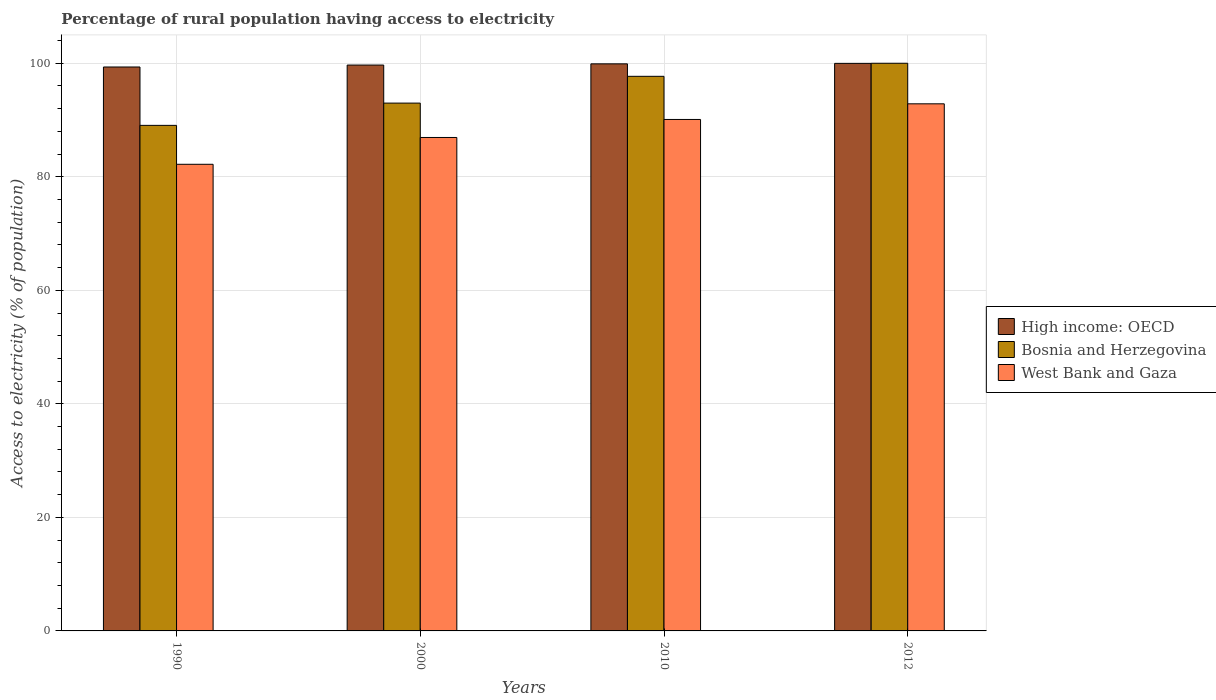Are the number of bars per tick equal to the number of legend labels?
Keep it short and to the point. Yes. Are the number of bars on each tick of the X-axis equal?
Make the answer very short. Yes. How many bars are there on the 3rd tick from the left?
Offer a terse response. 3. What is the percentage of rural population having access to electricity in West Bank and Gaza in 2010?
Your answer should be very brief. 90.1. Across all years, what is the maximum percentage of rural population having access to electricity in High income: OECD?
Your answer should be very brief. 99.98. Across all years, what is the minimum percentage of rural population having access to electricity in Bosnia and Herzegovina?
Provide a succinct answer. 89.06. In which year was the percentage of rural population having access to electricity in High income: OECD maximum?
Make the answer very short. 2012. In which year was the percentage of rural population having access to electricity in West Bank and Gaza minimum?
Your answer should be compact. 1990. What is the total percentage of rural population having access to electricity in Bosnia and Herzegovina in the graph?
Your response must be concise. 379.74. What is the difference between the percentage of rural population having access to electricity in Bosnia and Herzegovina in 1990 and that in 2000?
Provide a succinct answer. -3.92. What is the difference between the percentage of rural population having access to electricity in High income: OECD in 2000 and the percentage of rural population having access to electricity in Bosnia and Herzegovina in 2012?
Provide a succinct answer. -0.32. What is the average percentage of rural population having access to electricity in Bosnia and Herzegovina per year?
Your answer should be very brief. 94.94. In the year 2012, what is the difference between the percentage of rural population having access to electricity in West Bank and Gaza and percentage of rural population having access to electricity in High income: OECD?
Offer a very short reply. -7.13. What is the ratio of the percentage of rural population having access to electricity in Bosnia and Herzegovina in 2000 to that in 2012?
Provide a short and direct response. 0.93. Is the percentage of rural population having access to electricity in High income: OECD in 1990 less than that in 2012?
Offer a terse response. Yes. Is the difference between the percentage of rural population having access to electricity in West Bank and Gaza in 2010 and 2012 greater than the difference between the percentage of rural population having access to electricity in High income: OECD in 2010 and 2012?
Your answer should be very brief. No. What is the difference between the highest and the second highest percentage of rural population having access to electricity in High income: OECD?
Your answer should be very brief. 0.08. What is the difference between the highest and the lowest percentage of rural population having access to electricity in West Bank and Gaza?
Give a very brief answer. 10.65. What does the 1st bar from the left in 2010 represents?
Ensure brevity in your answer.  High income: OECD. What does the 2nd bar from the right in 1990 represents?
Your answer should be compact. Bosnia and Herzegovina. How many bars are there?
Offer a very short reply. 12. Are all the bars in the graph horizontal?
Keep it short and to the point. No. Does the graph contain grids?
Provide a short and direct response. Yes. Where does the legend appear in the graph?
Your answer should be very brief. Center right. How many legend labels are there?
Keep it short and to the point. 3. How are the legend labels stacked?
Give a very brief answer. Vertical. What is the title of the graph?
Your response must be concise. Percentage of rural population having access to electricity. Does "St. Kitts and Nevis" appear as one of the legend labels in the graph?
Give a very brief answer. No. What is the label or title of the Y-axis?
Provide a succinct answer. Access to electricity (% of population). What is the Access to electricity (% of population) in High income: OECD in 1990?
Your answer should be compact. 99.34. What is the Access to electricity (% of population) of Bosnia and Herzegovina in 1990?
Ensure brevity in your answer.  89.06. What is the Access to electricity (% of population) of West Bank and Gaza in 1990?
Provide a short and direct response. 82.2. What is the Access to electricity (% of population) in High income: OECD in 2000?
Your response must be concise. 99.68. What is the Access to electricity (% of population) in Bosnia and Herzegovina in 2000?
Make the answer very short. 92.98. What is the Access to electricity (% of population) of West Bank and Gaza in 2000?
Keep it short and to the point. 86.93. What is the Access to electricity (% of population) of High income: OECD in 2010?
Keep it short and to the point. 99.9. What is the Access to electricity (% of population) of Bosnia and Herzegovina in 2010?
Ensure brevity in your answer.  97.7. What is the Access to electricity (% of population) in West Bank and Gaza in 2010?
Provide a succinct answer. 90.1. What is the Access to electricity (% of population) of High income: OECD in 2012?
Your answer should be very brief. 99.98. What is the Access to electricity (% of population) of Bosnia and Herzegovina in 2012?
Make the answer very short. 100. What is the Access to electricity (% of population) in West Bank and Gaza in 2012?
Give a very brief answer. 92.85. Across all years, what is the maximum Access to electricity (% of population) of High income: OECD?
Make the answer very short. 99.98. Across all years, what is the maximum Access to electricity (% of population) in Bosnia and Herzegovina?
Offer a terse response. 100. Across all years, what is the maximum Access to electricity (% of population) of West Bank and Gaza?
Ensure brevity in your answer.  92.85. Across all years, what is the minimum Access to electricity (% of population) of High income: OECD?
Offer a terse response. 99.34. Across all years, what is the minimum Access to electricity (% of population) of Bosnia and Herzegovina?
Keep it short and to the point. 89.06. Across all years, what is the minimum Access to electricity (% of population) of West Bank and Gaza?
Your answer should be very brief. 82.2. What is the total Access to electricity (% of population) in High income: OECD in the graph?
Your answer should be compact. 398.9. What is the total Access to electricity (% of population) of Bosnia and Herzegovina in the graph?
Keep it short and to the point. 379.74. What is the total Access to electricity (% of population) in West Bank and Gaza in the graph?
Provide a short and direct response. 352.08. What is the difference between the Access to electricity (% of population) of High income: OECD in 1990 and that in 2000?
Your answer should be compact. -0.34. What is the difference between the Access to electricity (% of population) in Bosnia and Herzegovina in 1990 and that in 2000?
Provide a short and direct response. -3.92. What is the difference between the Access to electricity (% of population) in West Bank and Gaza in 1990 and that in 2000?
Keep it short and to the point. -4.72. What is the difference between the Access to electricity (% of population) of High income: OECD in 1990 and that in 2010?
Offer a very short reply. -0.55. What is the difference between the Access to electricity (% of population) of Bosnia and Herzegovina in 1990 and that in 2010?
Ensure brevity in your answer.  -8.64. What is the difference between the Access to electricity (% of population) in West Bank and Gaza in 1990 and that in 2010?
Offer a terse response. -7.9. What is the difference between the Access to electricity (% of population) in High income: OECD in 1990 and that in 2012?
Provide a succinct answer. -0.64. What is the difference between the Access to electricity (% of population) in Bosnia and Herzegovina in 1990 and that in 2012?
Offer a terse response. -10.94. What is the difference between the Access to electricity (% of population) of West Bank and Gaza in 1990 and that in 2012?
Ensure brevity in your answer.  -10.65. What is the difference between the Access to electricity (% of population) of High income: OECD in 2000 and that in 2010?
Ensure brevity in your answer.  -0.21. What is the difference between the Access to electricity (% of population) in Bosnia and Herzegovina in 2000 and that in 2010?
Your answer should be very brief. -4.72. What is the difference between the Access to electricity (% of population) in West Bank and Gaza in 2000 and that in 2010?
Provide a short and direct response. -3.17. What is the difference between the Access to electricity (% of population) in High income: OECD in 2000 and that in 2012?
Ensure brevity in your answer.  -0.3. What is the difference between the Access to electricity (% of population) of Bosnia and Herzegovina in 2000 and that in 2012?
Provide a succinct answer. -7.02. What is the difference between the Access to electricity (% of population) of West Bank and Gaza in 2000 and that in 2012?
Offer a very short reply. -5.93. What is the difference between the Access to electricity (% of population) of High income: OECD in 2010 and that in 2012?
Offer a terse response. -0.08. What is the difference between the Access to electricity (% of population) in West Bank and Gaza in 2010 and that in 2012?
Your answer should be compact. -2.75. What is the difference between the Access to electricity (% of population) of High income: OECD in 1990 and the Access to electricity (% of population) of Bosnia and Herzegovina in 2000?
Offer a very short reply. 6.36. What is the difference between the Access to electricity (% of population) in High income: OECD in 1990 and the Access to electricity (% of population) in West Bank and Gaza in 2000?
Give a very brief answer. 12.42. What is the difference between the Access to electricity (% of population) of Bosnia and Herzegovina in 1990 and the Access to electricity (% of population) of West Bank and Gaza in 2000?
Your answer should be compact. 2.13. What is the difference between the Access to electricity (% of population) of High income: OECD in 1990 and the Access to electricity (% of population) of Bosnia and Herzegovina in 2010?
Your answer should be very brief. 1.64. What is the difference between the Access to electricity (% of population) in High income: OECD in 1990 and the Access to electricity (% of population) in West Bank and Gaza in 2010?
Your answer should be compact. 9.24. What is the difference between the Access to electricity (% of population) of Bosnia and Herzegovina in 1990 and the Access to electricity (% of population) of West Bank and Gaza in 2010?
Your answer should be compact. -1.04. What is the difference between the Access to electricity (% of population) of High income: OECD in 1990 and the Access to electricity (% of population) of Bosnia and Herzegovina in 2012?
Make the answer very short. -0.66. What is the difference between the Access to electricity (% of population) of High income: OECD in 1990 and the Access to electricity (% of population) of West Bank and Gaza in 2012?
Your response must be concise. 6.49. What is the difference between the Access to electricity (% of population) of Bosnia and Herzegovina in 1990 and the Access to electricity (% of population) of West Bank and Gaza in 2012?
Your response must be concise. -3.79. What is the difference between the Access to electricity (% of population) in High income: OECD in 2000 and the Access to electricity (% of population) in Bosnia and Herzegovina in 2010?
Give a very brief answer. 1.98. What is the difference between the Access to electricity (% of population) of High income: OECD in 2000 and the Access to electricity (% of population) of West Bank and Gaza in 2010?
Offer a terse response. 9.58. What is the difference between the Access to electricity (% of population) of Bosnia and Herzegovina in 2000 and the Access to electricity (% of population) of West Bank and Gaza in 2010?
Your answer should be very brief. 2.88. What is the difference between the Access to electricity (% of population) of High income: OECD in 2000 and the Access to electricity (% of population) of Bosnia and Herzegovina in 2012?
Your answer should be compact. -0.32. What is the difference between the Access to electricity (% of population) in High income: OECD in 2000 and the Access to electricity (% of population) in West Bank and Gaza in 2012?
Offer a very short reply. 6.83. What is the difference between the Access to electricity (% of population) of Bosnia and Herzegovina in 2000 and the Access to electricity (% of population) of West Bank and Gaza in 2012?
Your answer should be very brief. 0.13. What is the difference between the Access to electricity (% of population) of High income: OECD in 2010 and the Access to electricity (% of population) of Bosnia and Herzegovina in 2012?
Ensure brevity in your answer.  -0.1. What is the difference between the Access to electricity (% of population) in High income: OECD in 2010 and the Access to electricity (% of population) in West Bank and Gaza in 2012?
Your response must be concise. 7.04. What is the difference between the Access to electricity (% of population) in Bosnia and Herzegovina in 2010 and the Access to electricity (% of population) in West Bank and Gaza in 2012?
Your answer should be compact. 4.85. What is the average Access to electricity (% of population) in High income: OECD per year?
Give a very brief answer. 99.73. What is the average Access to electricity (% of population) of Bosnia and Herzegovina per year?
Keep it short and to the point. 94.94. What is the average Access to electricity (% of population) of West Bank and Gaza per year?
Provide a succinct answer. 88.02. In the year 1990, what is the difference between the Access to electricity (% of population) of High income: OECD and Access to electricity (% of population) of Bosnia and Herzegovina?
Offer a terse response. 10.28. In the year 1990, what is the difference between the Access to electricity (% of population) in High income: OECD and Access to electricity (% of population) in West Bank and Gaza?
Your response must be concise. 17.14. In the year 1990, what is the difference between the Access to electricity (% of population) of Bosnia and Herzegovina and Access to electricity (% of population) of West Bank and Gaza?
Give a very brief answer. 6.86. In the year 2000, what is the difference between the Access to electricity (% of population) in High income: OECD and Access to electricity (% of population) in Bosnia and Herzegovina?
Provide a succinct answer. 6.7. In the year 2000, what is the difference between the Access to electricity (% of population) of High income: OECD and Access to electricity (% of population) of West Bank and Gaza?
Your answer should be compact. 12.76. In the year 2000, what is the difference between the Access to electricity (% of population) in Bosnia and Herzegovina and Access to electricity (% of population) in West Bank and Gaza?
Make the answer very short. 6.05. In the year 2010, what is the difference between the Access to electricity (% of population) of High income: OECD and Access to electricity (% of population) of Bosnia and Herzegovina?
Offer a terse response. 2.2. In the year 2010, what is the difference between the Access to electricity (% of population) of High income: OECD and Access to electricity (% of population) of West Bank and Gaza?
Offer a terse response. 9.8. In the year 2010, what is the difference between the Access to electricity (% of population) in Bosnia and Herzegovina and Access to electricity (% of population) in West Bank and Gaza?
Make the answer very short. 7.6. In the year 2012, what is the difference between the Access to electricity (% of population) of High income: OECD and Access to electricity (% of population) of Bosnia and Herzegovina?
Your answer should be compact. -0.02. In the year 2012, what is the difference between the Access to electricity (% of population) in High income: OECD and Access to electricity (% of population) in West Bank and Gaza?
Your response must be concise. 7.13. In the year 2012, what is the difference between the Access to electricity (% of population) of Bosnia and Herzegovina and Access to electricity (% of population) of West Bank and Gaza?
Ensure brevity in your answer.  7.15. What is the ratio of the Access to electricity (% of population) of Bosnia and Herzegovina in 1990 to that in 2000?
Keep it short and to the point. 0.96. What is the ratio of the Access to electricity (% of population) of West Bank and Gaza in 1990 to that in 2000?
Your answer should be compact. 0.95. What is the ratio of the Access to electricity (% of population) in Bosnia and Herzegovina in 1990 to that in 2010?
Provide a succinct answer. 0.91. What is the ratio of the Access to electricity (% of population) of West Bank and Gaza in 1990 to that in 2010?
Give a very brief answer. 0.91. What is the ratio of the Access to electricity (% of population) of Bosnia and Herzegovina in 1990 to that in 2012?
Offer a terse response. 0.89. What is the ratio of the Access to electricity (% of population) of West Bank and Gaza in 1990 to that in 2012?
Keep it short and to the point. 0.89. What is the ratio of the Access to electricity (% of population) of Bosnia and Herzegovina in 2000 to that in 2010?
Offer a very short reply. 0.95. What is the ratio of the Access to electricity (% of population) in West Bank and Gaza in 2000 to that in 2010?
Make the answer very short. 0.96. What is the ratio of the Access to electricity (% of population) in Bosnia and Herzegovina in 2000 to that in 2012?
Your response must be concise. 0.93. What is the ratio of the Access to electricity (% of population) of West Bank and Gaza in 2000 to that in 2012?
Make the answer very short. 0.94. What is the ratio of the Access to electricity (% of population) in Bosnia and Herzegovina in 2010 to that in 2012?
Make the answer very short. 0.98. What is the ratio of the Access to electricity (% of population) of West Bank and Gaza in 2010 to that in 2012?
Provide a succinct answer. 0.97. What is the difference between the highest and the second highest Access to electricity (% of population) in High income: OECD?
Offer a terse response. 0.08. What is the difference between the highest and the second highest Access to electricity (% of population) of West Bank and Gaza?
Your answer should be very brief. 2.75. What is the difference between the highest and the lowest Access to electricity (% of population) in High income: OECD?
Ensure brevity in your answer.  0.64. What is the difference between the highest and the lowest Access to electricity (% of population) of Bosnia and Herzegovina?
Give a very brief answer. 10.94. What is the difference between the highest and the lowest Access to electricity (% of population) in West Bank and Gaza?
Your answer should be very brief. 10.65. 